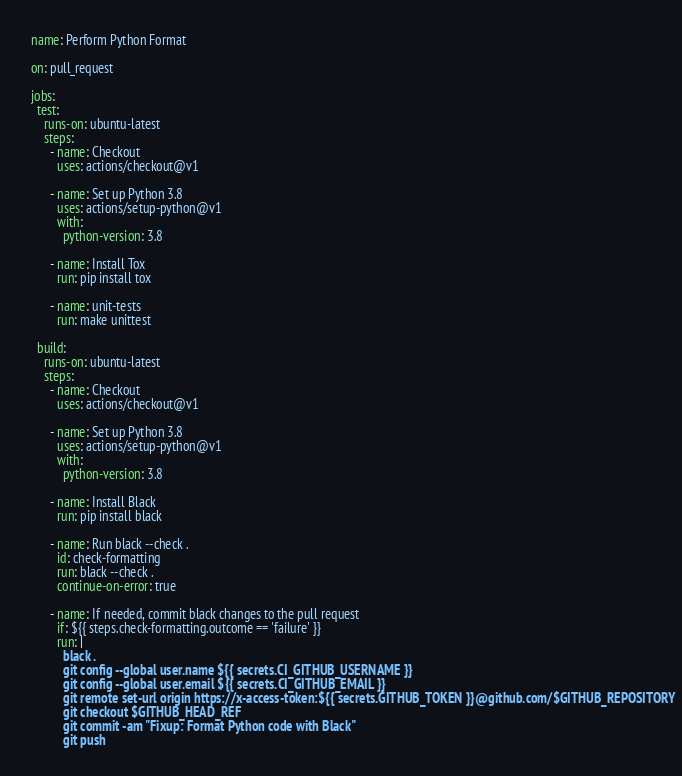Convert code to text. <code><loc_0><loc_0><loc_500><loc_500><_YAML_>name: Perform Python Format

on: pull_request

jobs:
  test:
    runs-on: ubuntu-latest
    steps:
      - name: Checkout
        uses: actions/checkout@v1

      - name: Set up Python 3.8
        uses: actions/setup-python@v1
        with:
          python-version: 3.8

      - name: Install Tox
        run: pip install tox

      - name: unit-tests
        run: make unittest

  build:
    runs-on: ubuntu-latest
    steps:
      - name: Checkout
        uses: actions/checkout@v1

      - name: Set up Python 3.8
        uses: actions/setup-python@v1
        with:
          python-version: 3.8

      - name: Install Black
        run: pip install black

      - name: Run black --check .
        id: check-formatting
        run: black --check .
        continue-on-error: true

      - name: If needed, commit black changes to the pull request
        if: ${{ steps.check-formatting.outcome == 'failure' }}
        run: |
          black .
          git config --global user.name ${{ secrets.CI_GITHUB_USERNAME }}
          git config --global user.email ${{ secrets.CI_GITHUB_EMAIL }}
          git remote set-url origin https://x-access-token:${{ secrets.GITHUB_TOKEN }}@github.com/$GITHUB_REPOSITORY
          git checkout $GITHUB_HEAD_REF
          git commit -am "Fixup: Format Python code with Black"
          git push
</code> 